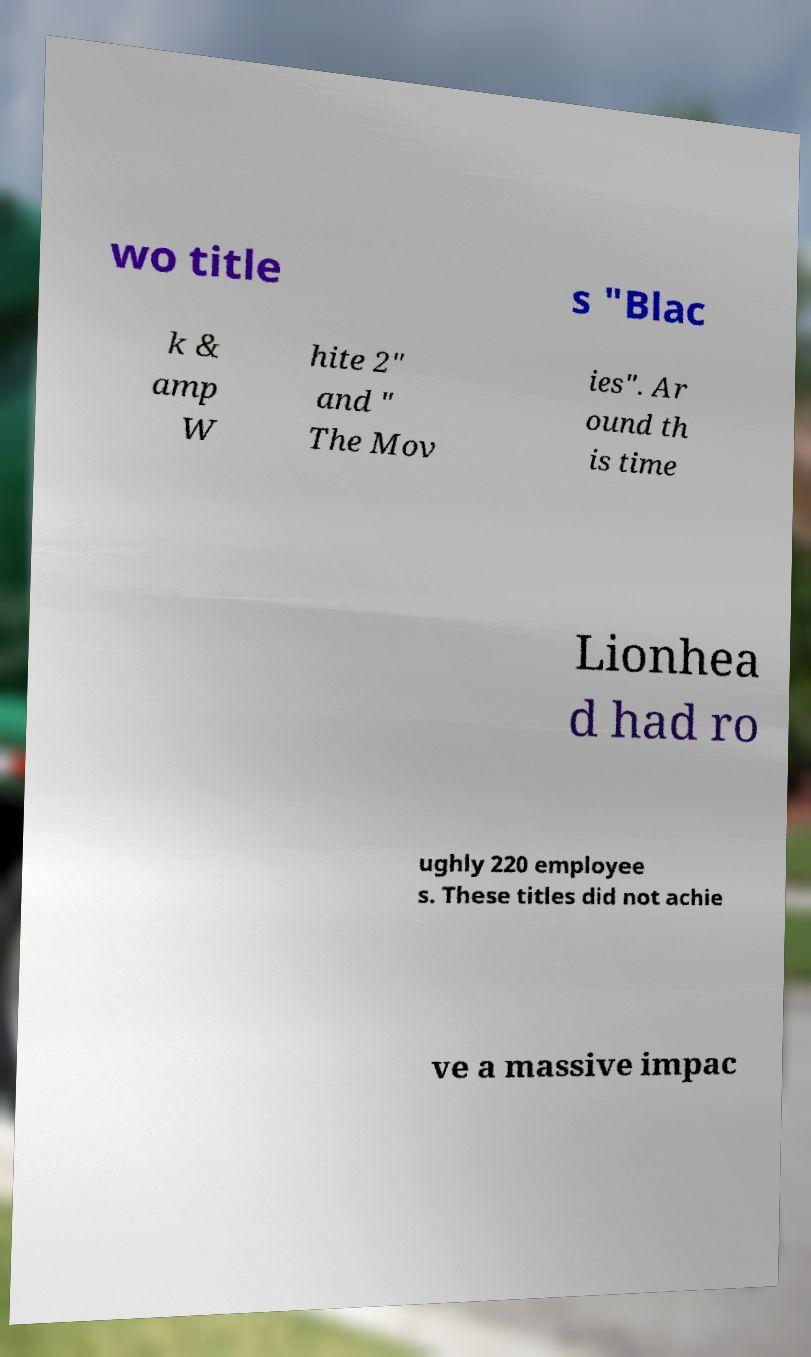Please read and relay the text visible in this image. What does it say? wo title s "Blac k & amp W hite 2" and " The Mov ies". Ar ound th is time Lionhea d had ro ughly 220 employee s. These titles did not achie ve a massive impac 